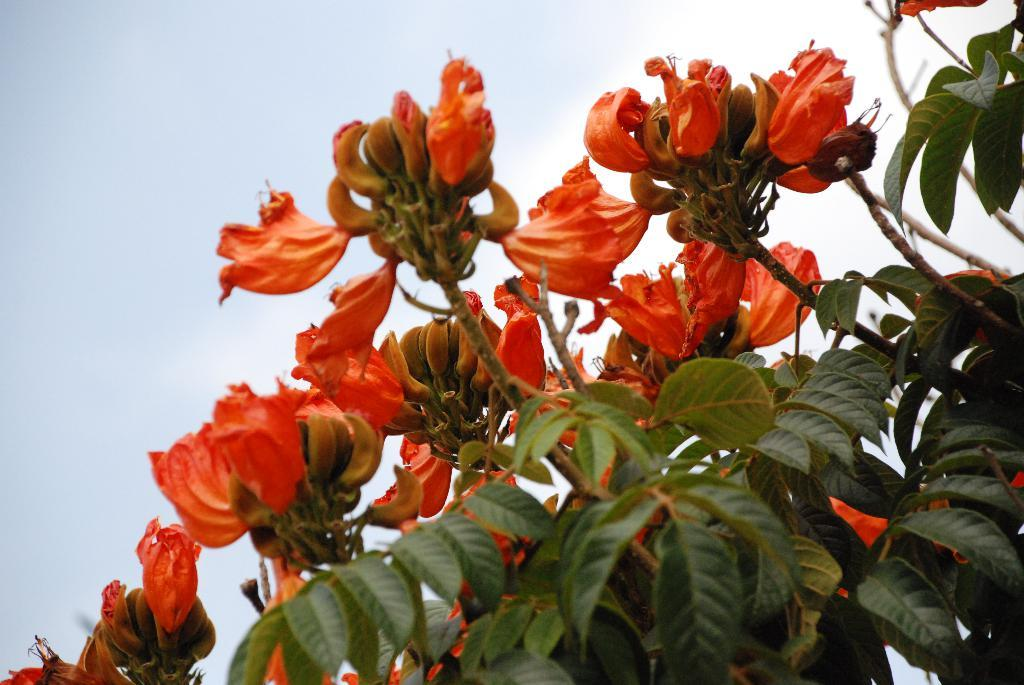What is present in the image? There is a plant in the image. What specific feature of the plant can be observed? The plant has flowers. What color are the flowers? The flowers are orange in color. Is the plant in the image showing any signs of temper? There is no indication of temper in the plant, as plants do not have emotions. 